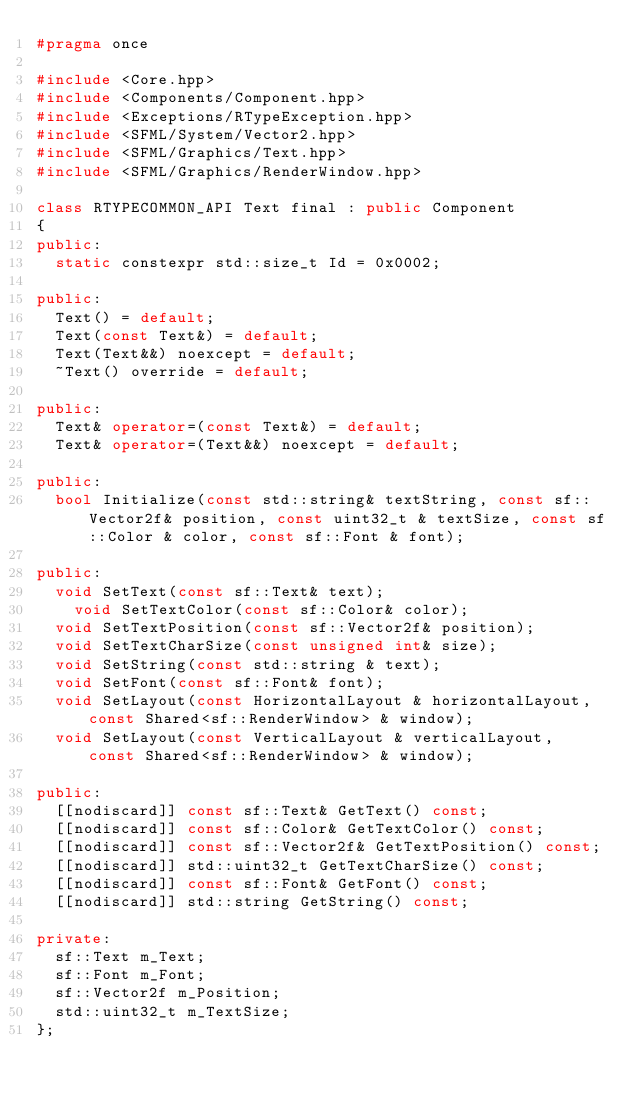Convert code to text. <code><loc_0><loc_0><loc_500><loc_500><_C++_>#pragma once

#include <Core.hpp>
#include <Components/Component.hpp>
#include <Exceptions/RTypeException.hpp>
#include <SFML/System/Vector2.hpp>
#include <SFML/Graphics/Text.hpp>
#include <SFML/Graphics/RenderWindow.hpp>

class RTYPECOMMON_API Text final : public Component
{
public:
	static constexpr std::size_t Id = 0x0002;

public:
	Text() = default;
	Text(const Text&) = default;
	Text(Text&&) noexcept = default;
	~Text() override = default;

public:
	Text& operator=(const Text&) = default;
	Text& operator=(Text&&) noexcept = default;

public:
	bool Initialize(const std::string& textString, const sf::Vector2f& position, const uint32_t & textSize, const sf::Color & color, const sf::Font & font);

public:
	void SetText(const sf::Text& text);
    void SetTextColor(const sf::Color& color);
	void SetTextPosition(const sf::Vector2f& position);
	void SetTextCharSize(const unsigned int& size);
	void SetString(const std::string & text);
	void SetFont(const sf::Font& font);
	void SetLayout(const HorizontalLayout & horizontalLayout, const Shared<sf::RenderWindow> & window);
	void SetLayout(const VerticalLayout & verticalLayout, const Shared<sf::RenderWindow> & window);

public:
	[[nodiscard]] const sf::Text& GetText() const;
	[[nodiscard]] const sf::Color& GetTextColor() const;
	[[nodiscard]] const sf::Vector2f& GetTextPosition() const;
	[[nodiscard]] std::uint32_t GetTextCharSize() const;
	[[nodiscard]] const sf::Font& GetFont() const;
	[[nodiscard]] std::string GetString() const;

private:
	sf::Text m_Text;
	sf::Font m_Font;
	sf::Vector2f m_Position;
	std::uint32_t m_TextSize;
};</code> 